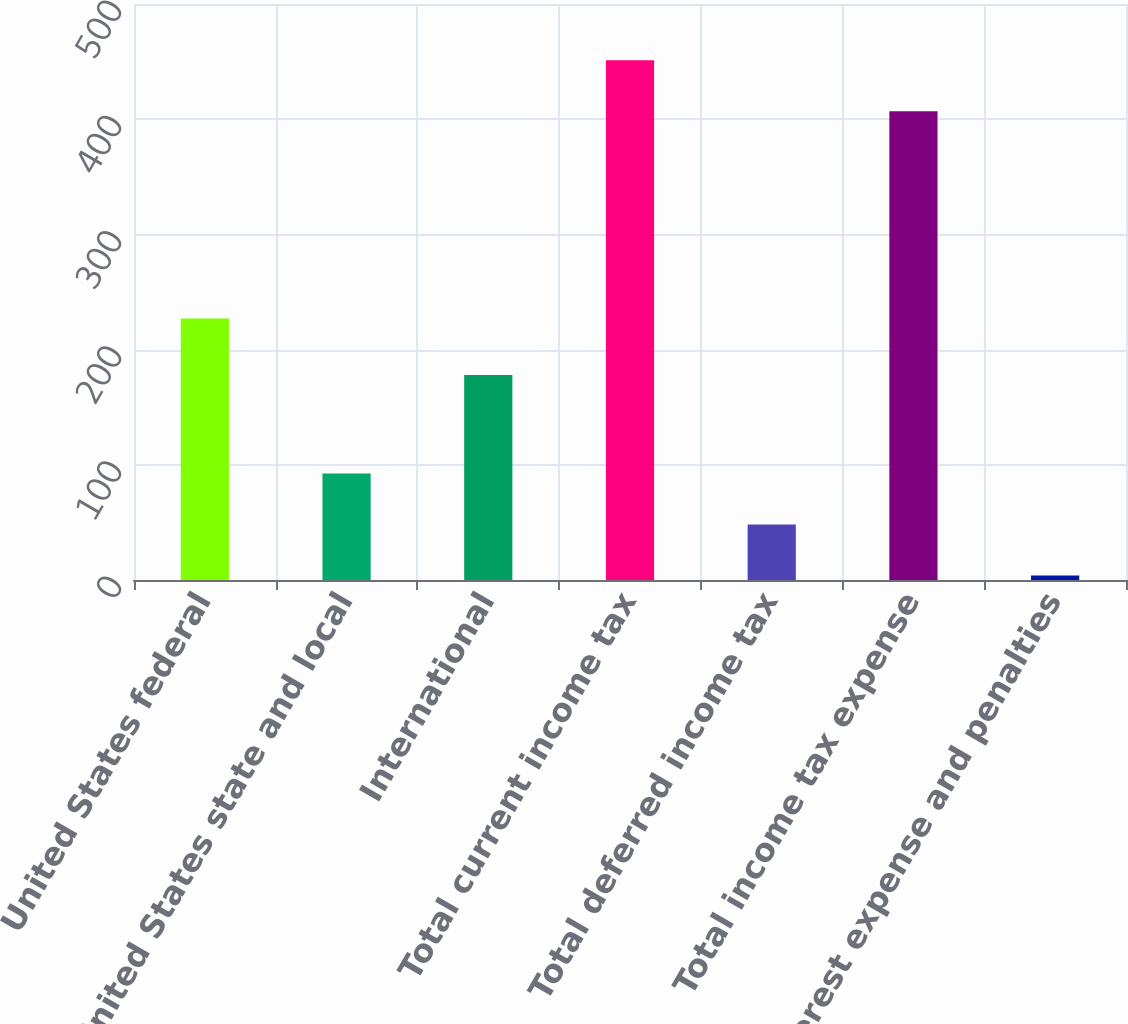Convert chart to OTSL. <chart><loc_0><loc_0><loc_500><loc_500><bar_chart><fcel>United States federal<fcel>United States state and local<fcel>International<fcel>Total current income tax<fcel>Total deferred income tax<fcel>Total income tax expense<fcel>Interest expense and penalties<nl><fcel>227<fcel>92.4<fcel>178<fcel>451.2<fcel>48.2<fcel>407<fcel>4<nl></chart> 